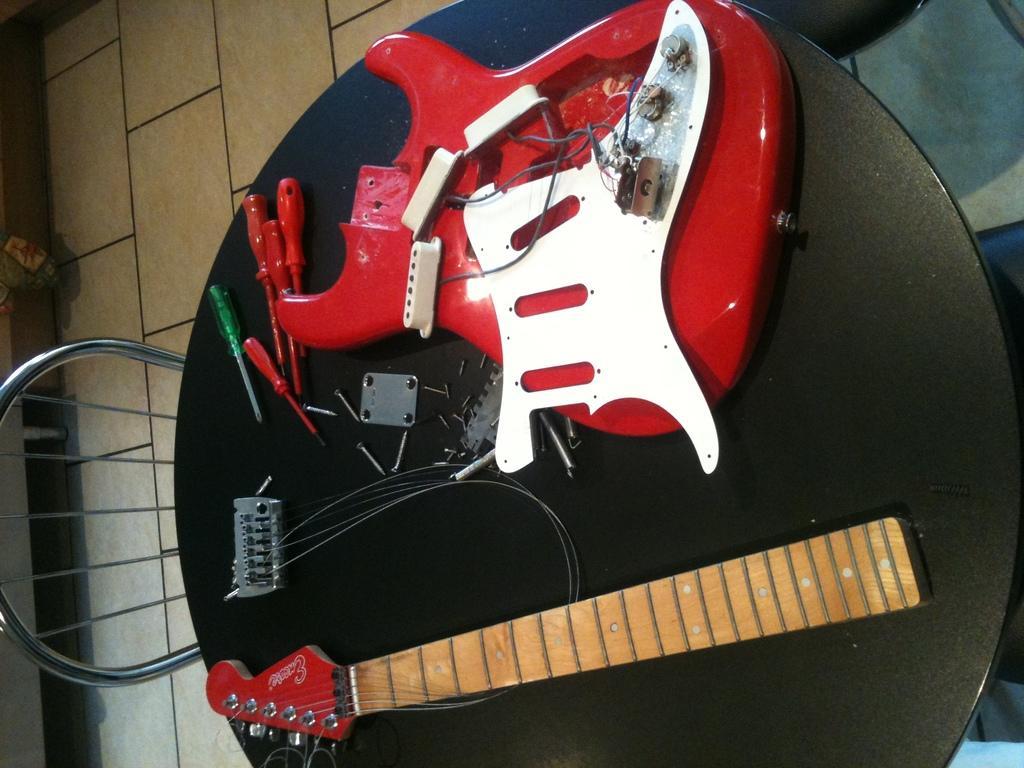Please provide a concise description of this image. In this image we can see a table, on that there are parts of a guitar, there are screwdrivers, screws, also we can see a chair. 